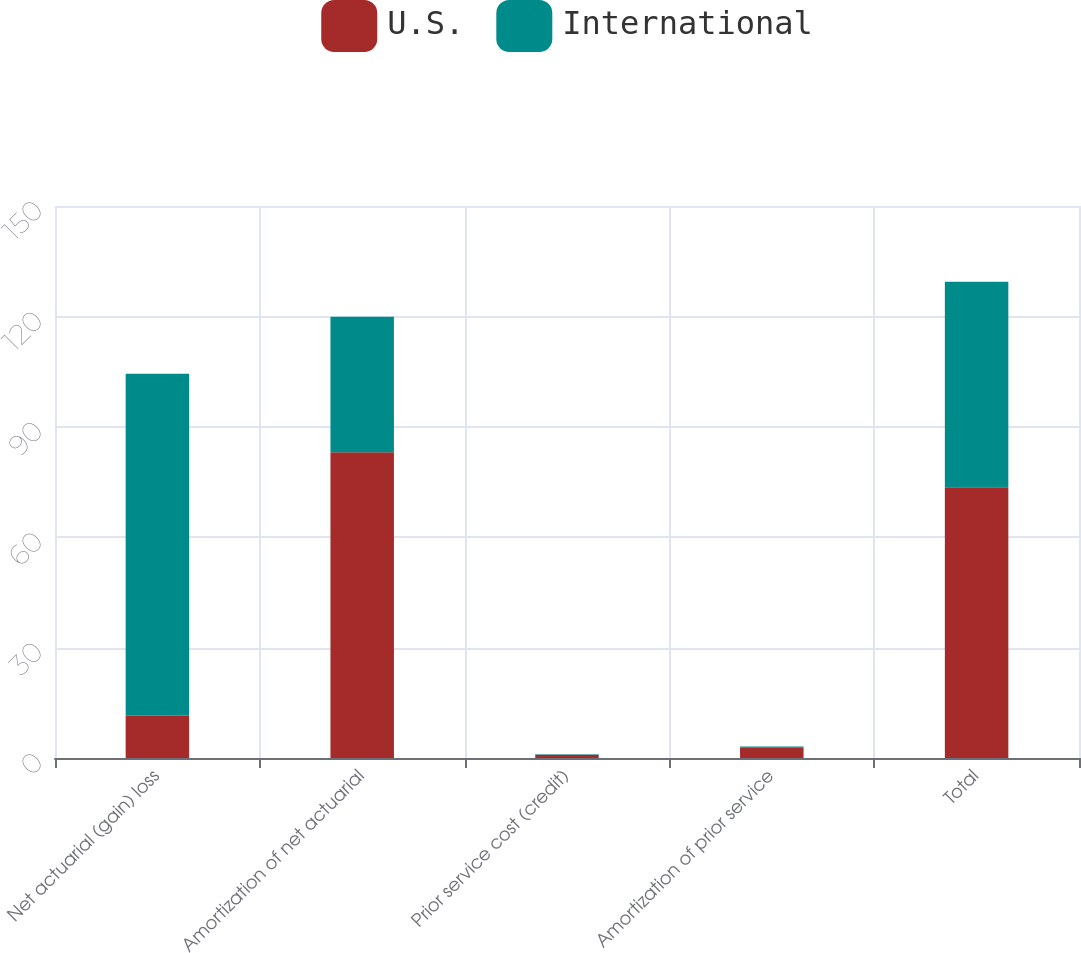<chart> <loc_0><loc_0><loc_500><loc_500><stacked_bar_chart><ecel><fcel>Net actuarial (gain) loss<fcel>Amortization of net actuarial<fcel>Prior service cost (credit)<fcel>Amortization of prior service<fcel>Total<nl><fcel>U.S.<fcel>11.5<fcel>83.1<fcel>0.9<fcel>2.9<fcel>73.6<nl><fcel>International<fcel>92.9<fcel>36.8<fcel>0.1<fcel>0.2<fcel>55.8<nl></chart> 